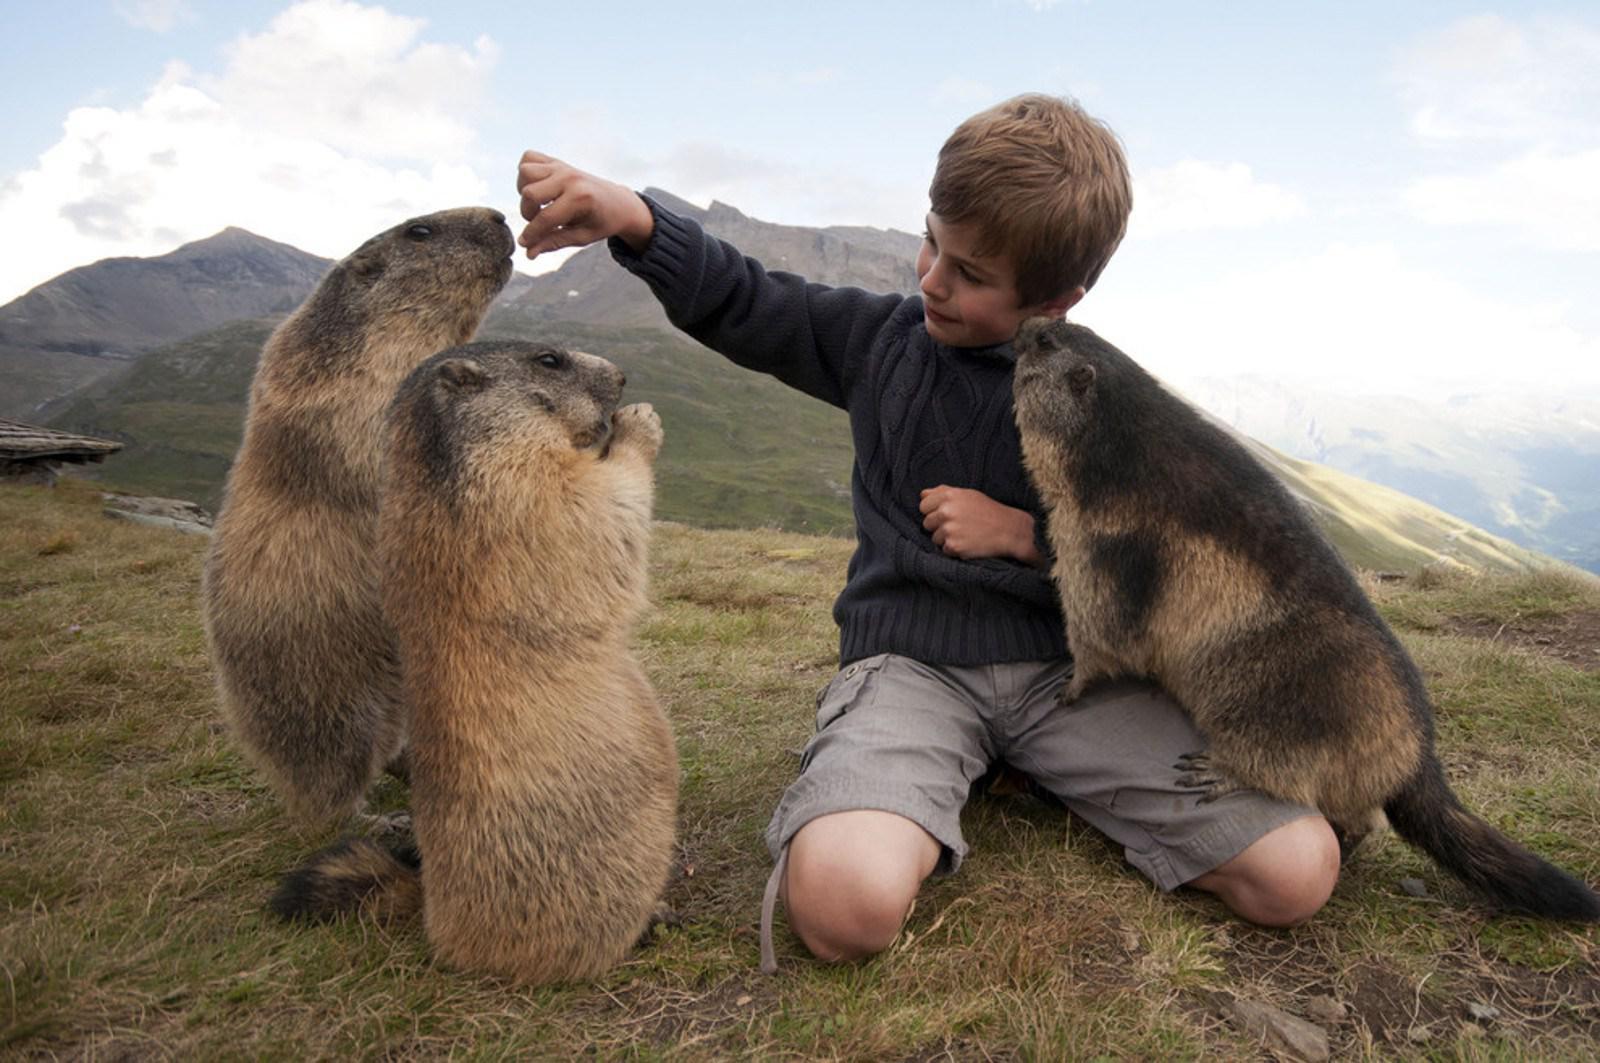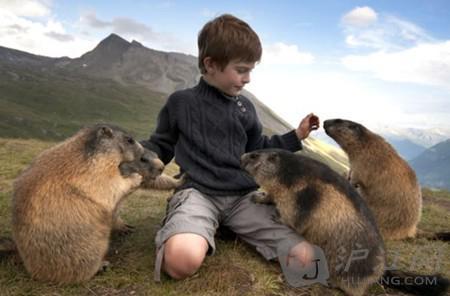The first image is the image on the left, the second image is the image on the right. Analyze the images presented: Is the assertion "In the right image, there are at least three animals interacting with a young boy." valid? Answer yes or no. Yes. The first image is the image on the left, the second image is the image on the right. Evaluate the accuracy of this statement regarding the images: "There are six marmots.". Is it true? Answer yes or no. Yes. 